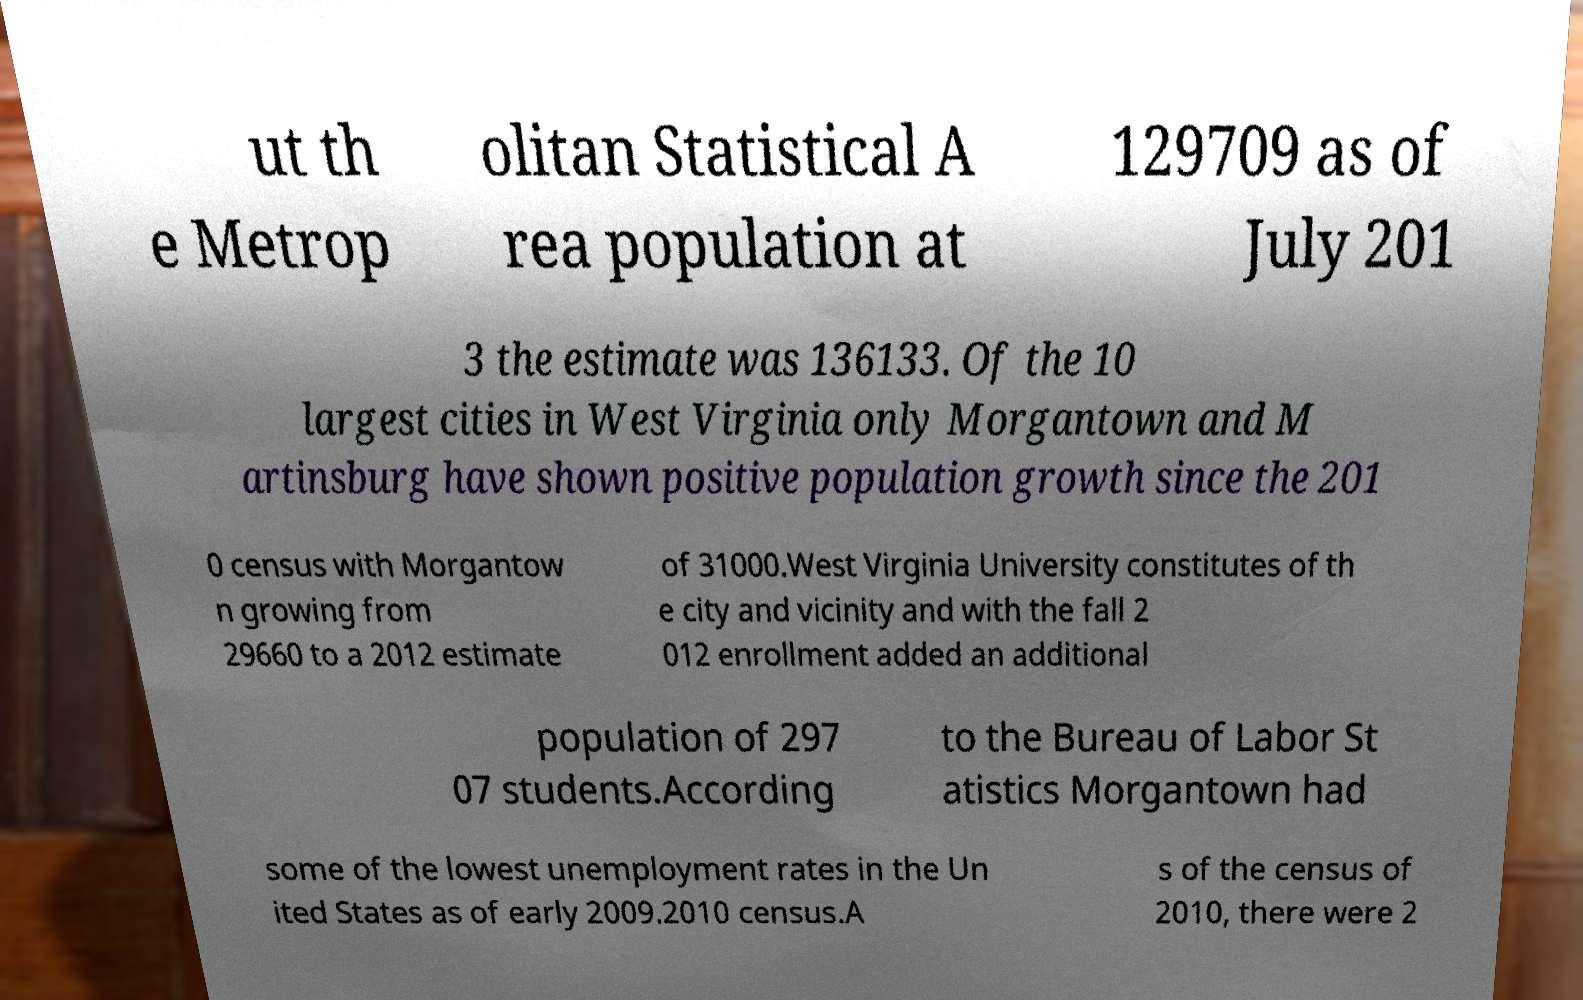For documentation purposes, I need the text within this image transcribed. Could you provide that? ut th e Metrop olitan Statistical A rea population at 129709 as of July 201 3 the estimate was 136133. Of the 10 largest cities in West Virginia only Morgantown and M artinsburg have shown positive population growth since the 201 0 census with Morgantow n growing from 29660 to a 2012 estimate of 31000.West Virginia University constitutes of th e city and vicinity and with the fall 2 012 enrollment added an additional population of 297 07 students.According to the Bureau of Labor St atistics Morgantown had some of the lowest unemployment rates in the Un ited States as of early 2009.2010 census.A s of the census of 2010, there were 2 